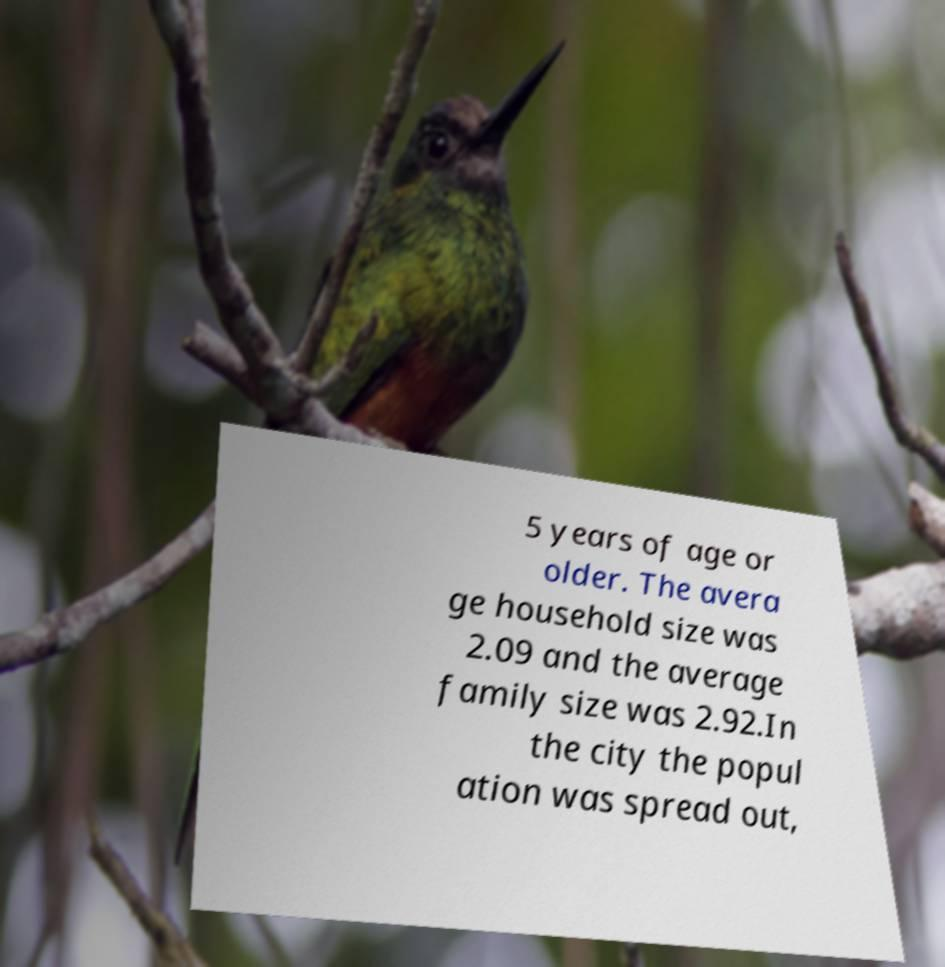Could you extract and type out the text from this image? 5 years of age or older. The avera ge household size was 2.09 and the average family size was 2.92.In the city the popul ation was spread out, 